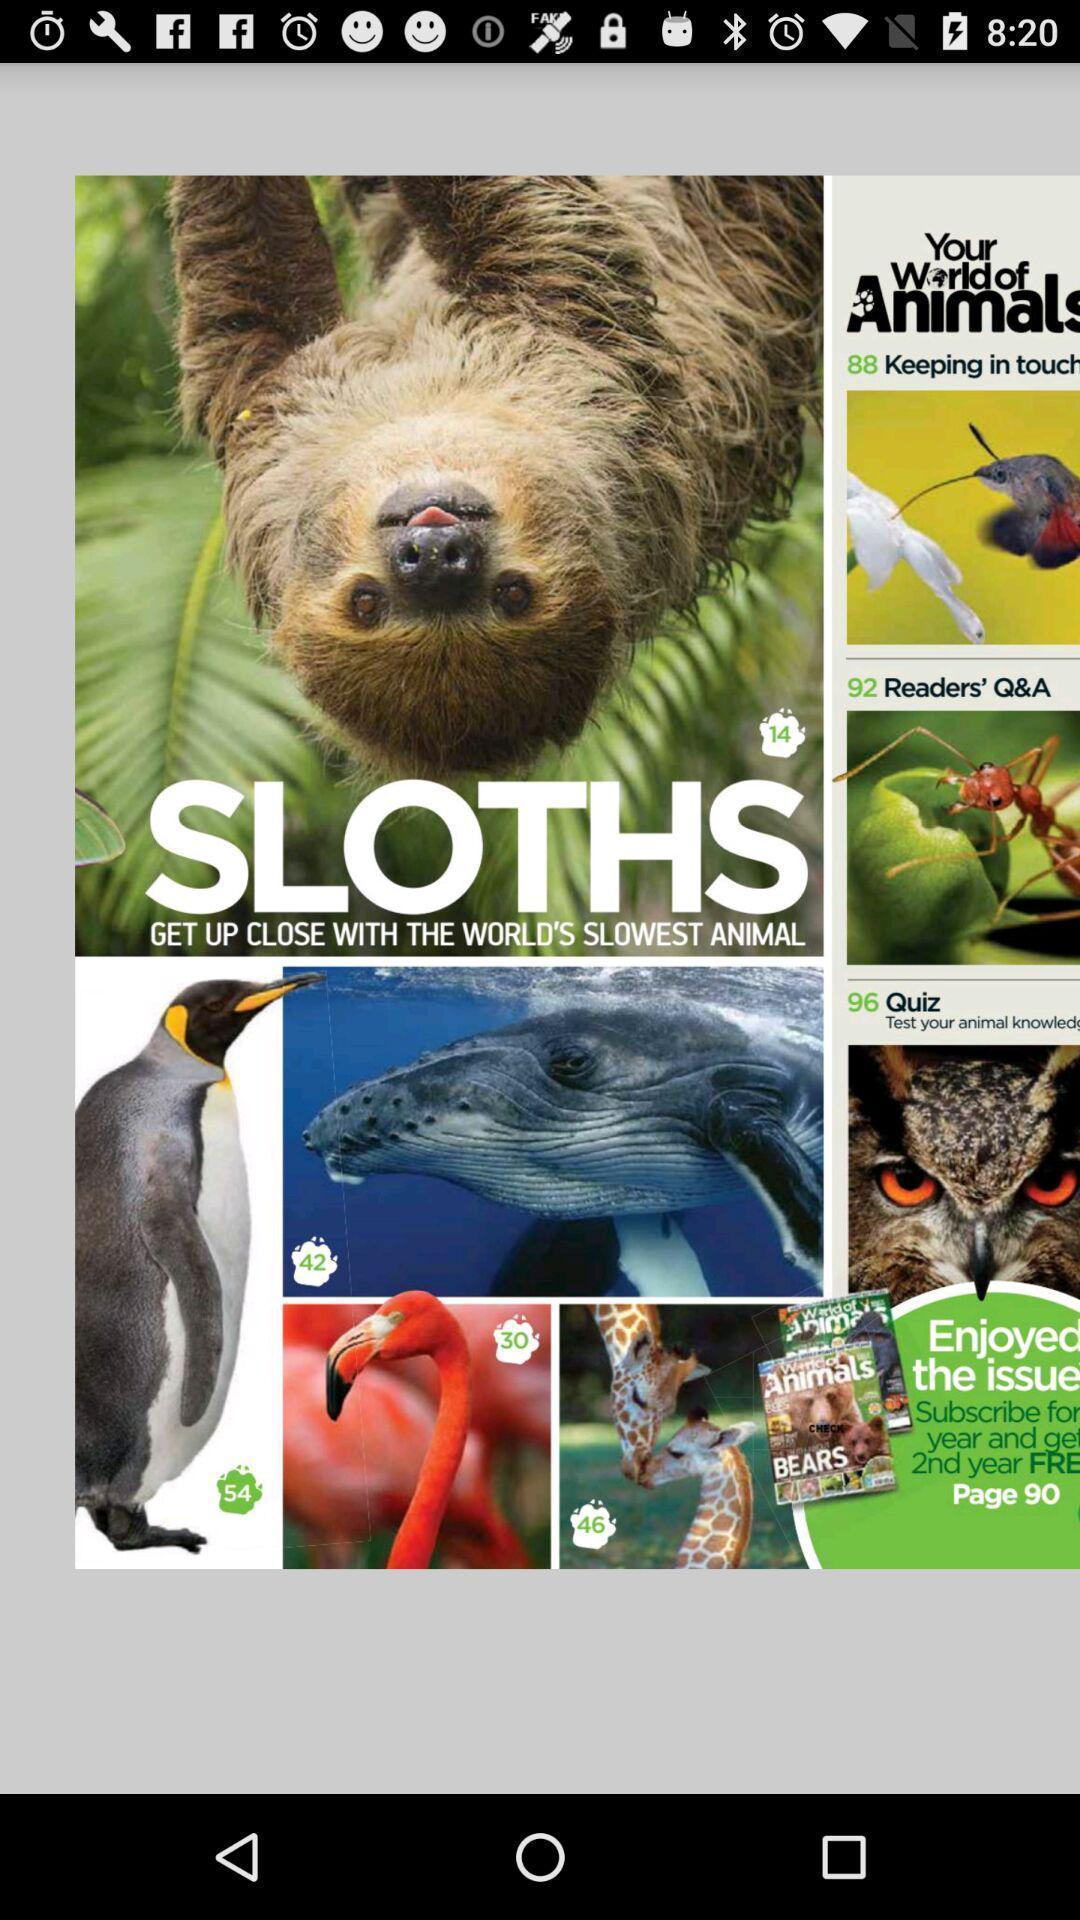What details can you identify in this image? Screen displaying multiple animal images. 